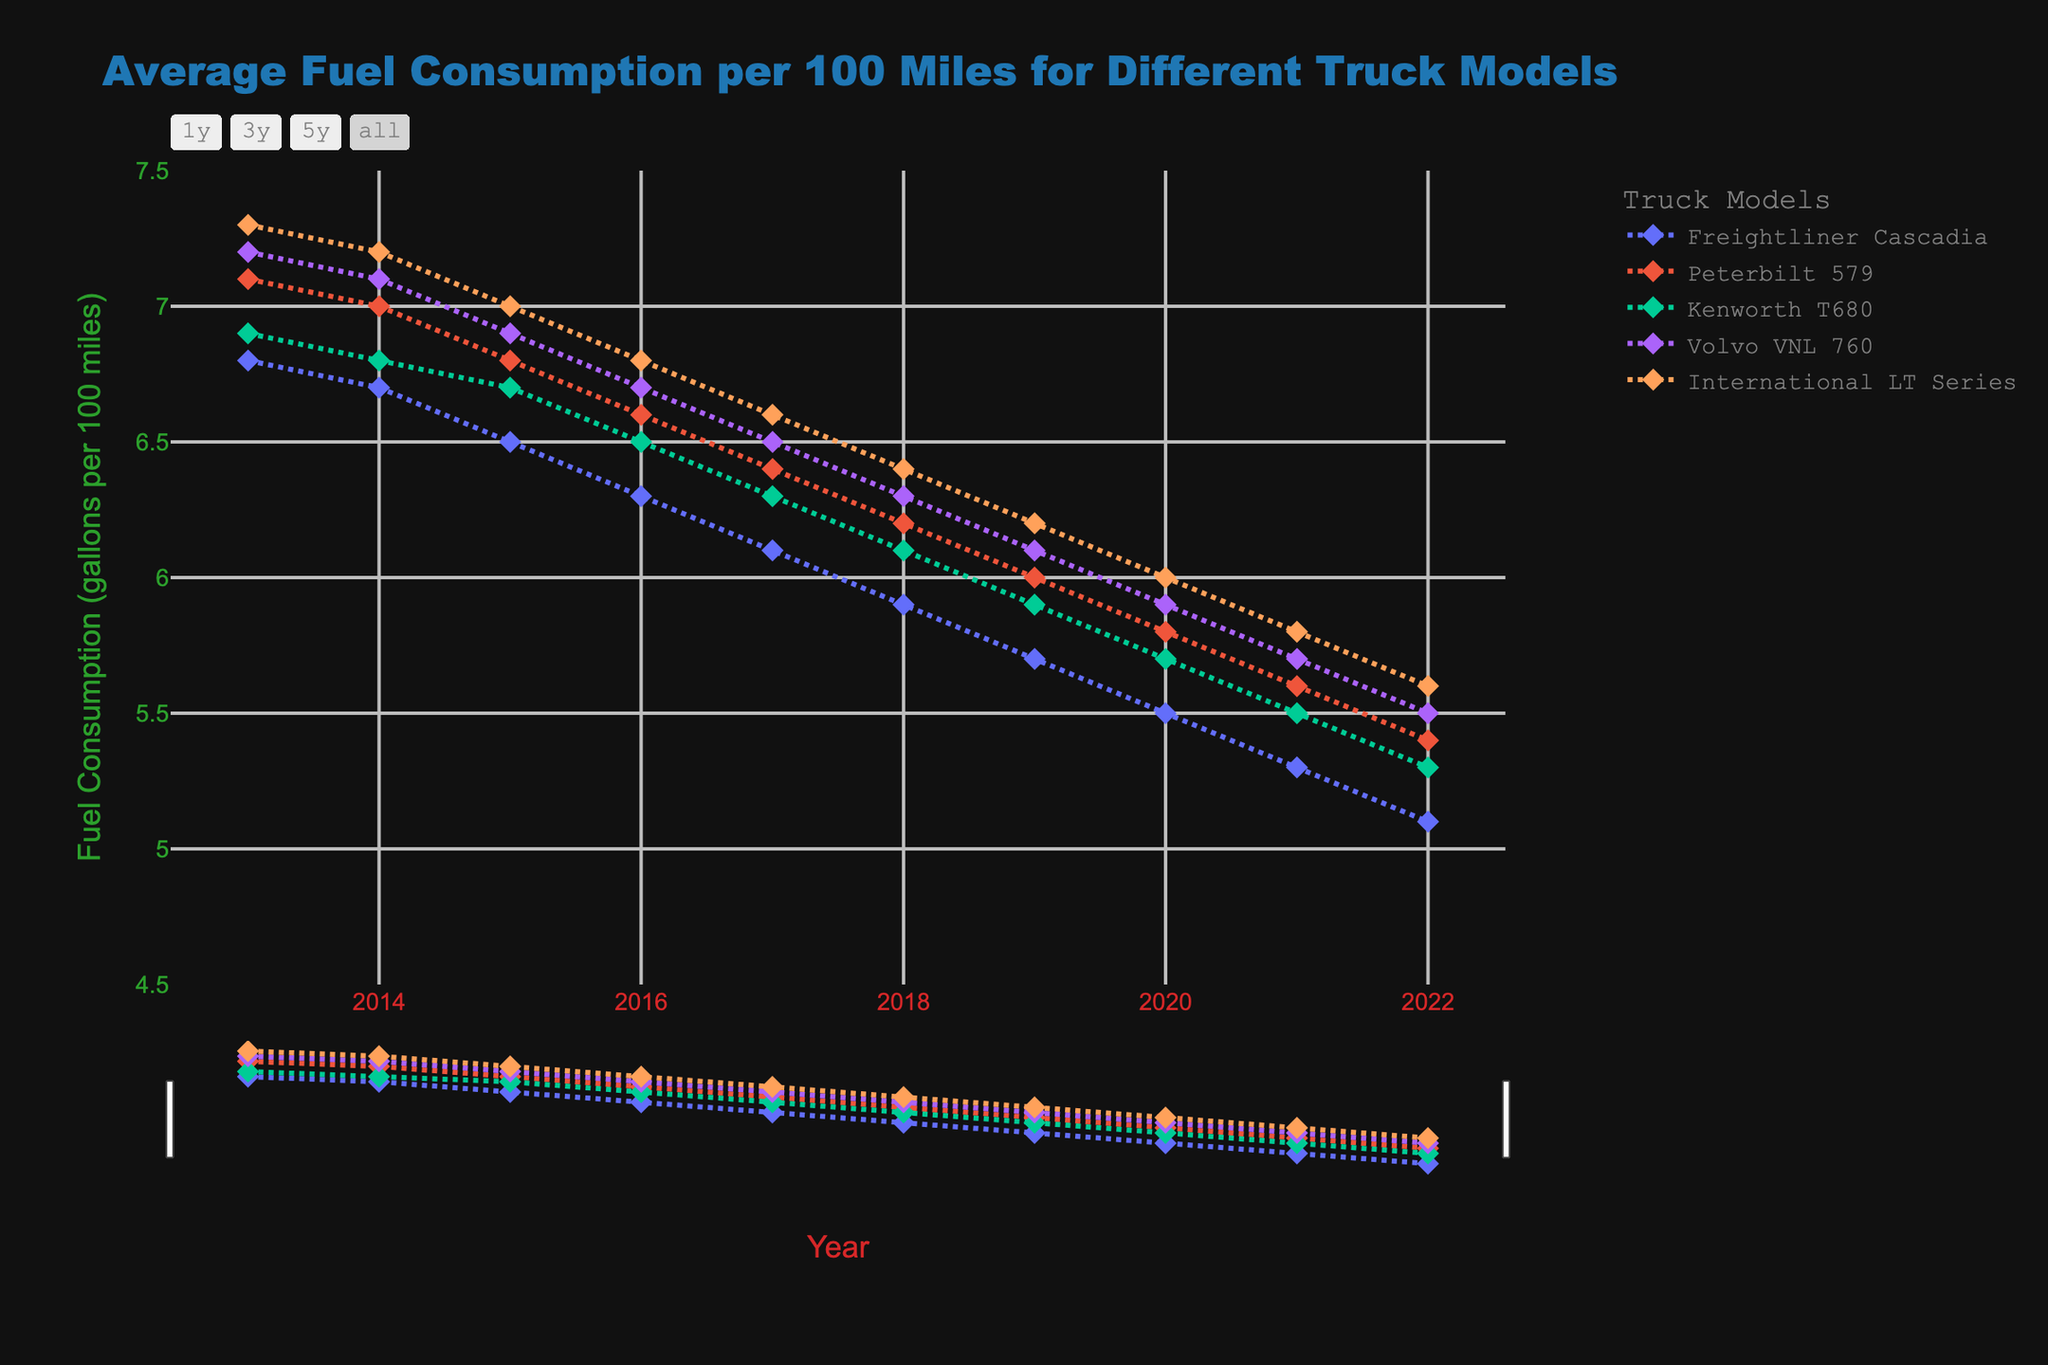What is the trend for the Freightliner Cascadia's fuel consumption over the past decade? The fuel consumption of the Freightliner Cascadia shows a consistent decrease from 6.8 gallons per 100 miles in 2013 to 5.1 gallons per 100 miles in 2022. This indicates an improvement in fuel efficiency over the years.
Answer: Consistent decrease Which truck model had the highest fuel consumption in 2015 and what was the value? In 2015, the truck model with the highest fuel consumption was the International LT Series with a value of 7.0 gallons per 100 miles. This can be observed by looking at the highest point on the y-axis for the year 2015 across all models.
Answer: International LT Series, 7.0 gallons per 100 miles Calculate the average fuel consumption for the Peterbilt 579 in 2021 and 2022. The fuel consumption for the Peterbilt 579 in 2021 is 5.6 gallons per 100 miles, and for 2022, it is 5.4 gallons per 100 miles. Adding these two values gives 11.0 gallons, and the average is 11.0 / 2 = 5.5 gallons per 100 miles.
Answer: 5.5 gallons per 100 miles Which truck model showed the least improvement in fuel efficiency from 2013 to 2022? Improvement in fuel efficiency can be assessed by the decrease in fuel consumption. The Freightliner Cascadia went from 6.8 to 5.1 (1.7 gallons drop), Peterbilt 579 from 7.1 to 5.4 (1.7 gallons drop), Kenworth T680 from 6.9 to 5.3 (1.6 gallons drop), Volvo VNL 760 from 7.2 to 5.5 (1.7 gallons drop), and International LT Series from 7.3 to 5.6 (1.7 gallons drop). The Kenworth T680 showed the least improvement with a 1.6-gallon drop.
Answer: Kenworth T680 In which year do all models have fuel consumption values below 6 gallons per 100 miles? By looking at the y-axis values for all models, in 2021, all models (Freightliner Cascadia, Peterbilt 579, Kenworth T680, Volvo VNL 760, and International LT Series) have values below 6 gallons per 100 miles.
Answer: 2021 Compare the fuel consumption trends of the Peterbilt 579 and Kenworth T680 from 2013 to 2022. Which model had more consistent improvement? Both Peterbilt 579 and Kenworth T680 show declining trends, but Peterbilt 579 starts at 7.1 and drops to 5.4 (1.7-gallon drop), whereas Kenworth T680 starts at 6.9 and drops to 5.3 (1.6-gallon drop). The Peterbilt 579 has a more consistent and slightly greater improvement.
Answer: Peterbilt 579 Which truck model had the smallest range of fuel consumption values over the past decade, and what is the range? The range is the difference between the maximum and minimum values for each model. Freightliner Cascadia ranges from 6.8 to 5.1 (1.7), Peterbilt 579 from 7.1 to 5.4 (1.7), Kenworth T680 from 6.9 to 5.3 (1.6), Volvo VNL 760 from 7.2 to 5.5 (1.7), and International LT Series from 7.3 to 5.6 (1.7). Kenworth T680 has the smallest range of 1.6 gallons.
Answer: Kenworth T680, 1.6 gallons How did the fuel consumption of the Volvo VNL 760 change between 2016 and 2019? In 2016, the fuel consumption of Volvo VNL 760 was 6.7 gallons per 100 miles. By 2019, it decreased to 6.1 gallons per 100 miles. The change in fuel consumption is 6.7 - 6.1 = 0.6 gallons per 100 miles.
Answer: Decreased by 0.6 gallons per 100 miles What is the difference in fuel consumption between the highest and lowest model in 2020? In 2020, the highest fuel consumption is by the International LT Series at 6.0 gallons per 100 miles, and the lowest is by the Freightliner Cascadia at 5.5 gallons per 100 miles. The difference is 6.0 - 5.5 = 0.5 gallons per 100 miles.
Answer: 0.5 gallons per 100 miles 